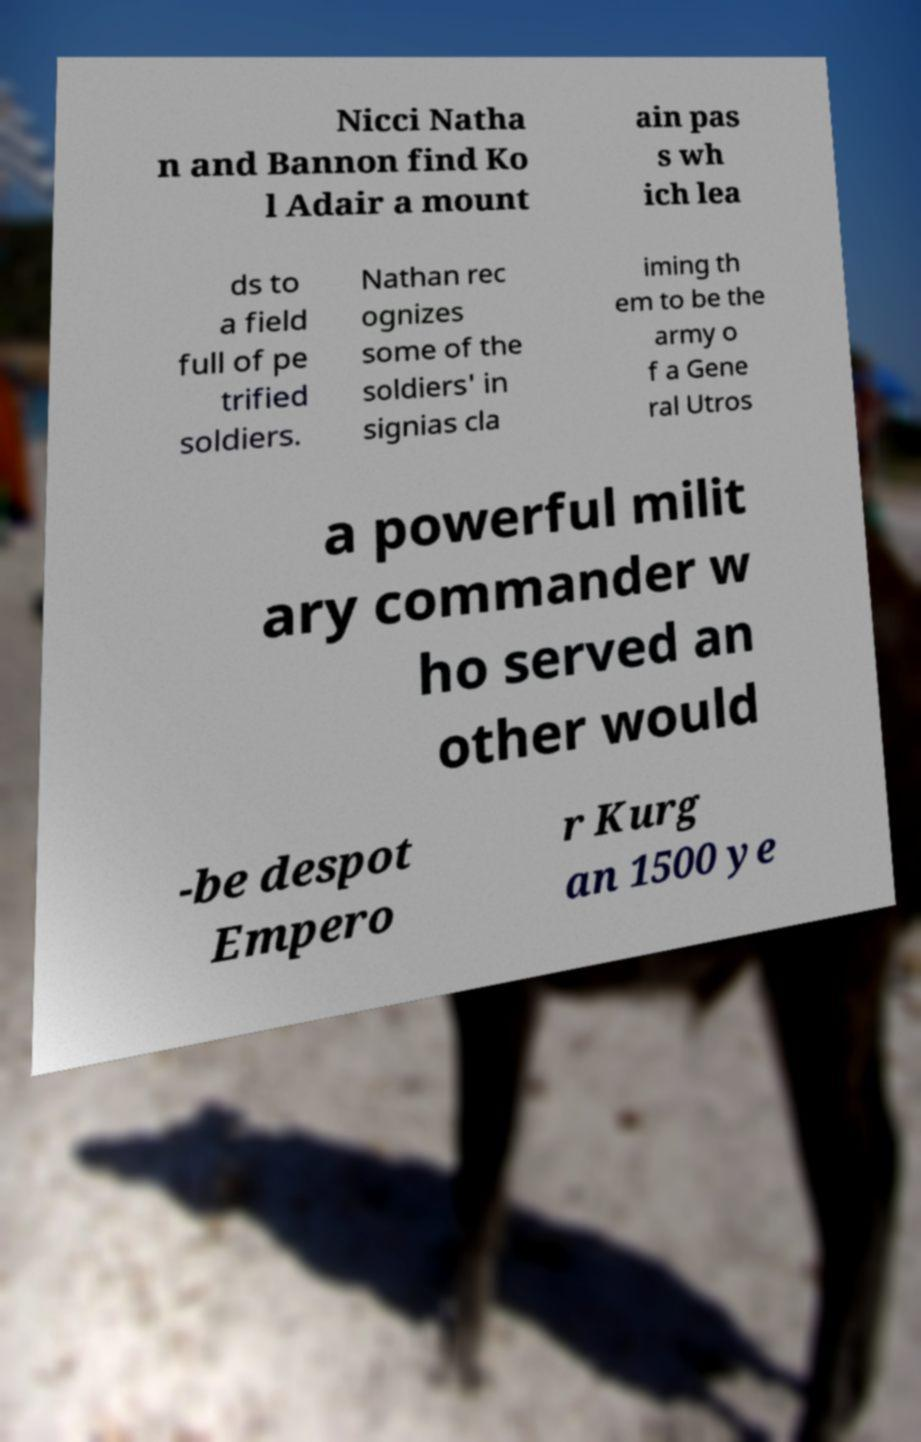Could you assist in decoding the text presented in this image and type it out clearly? Nicci Natha n and Bannon find Ko l Adair a mount ain pas s wh ich lea ds to a field full of pe trified soldiers. Nathan rec ognizes some of the soldiers' in signias cla iming th em to be the army o f a Gene ral Utros a powerful milit ary commander w ho served an other would -be despot Empero r Kurg an 1500 ye 